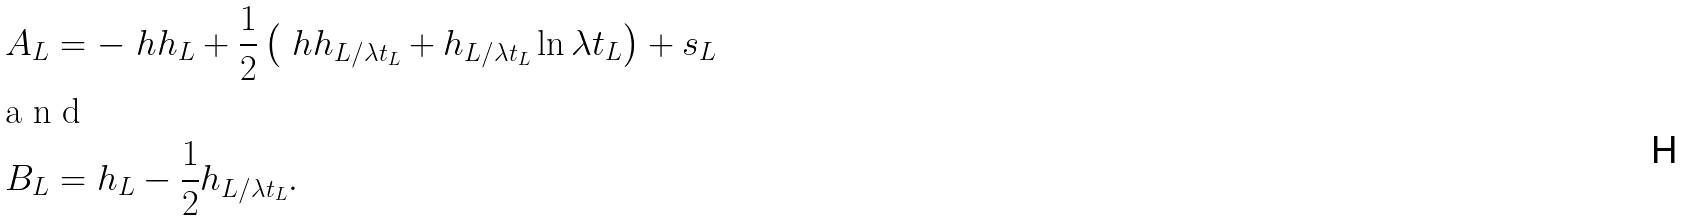<formula> <loc_0><loc_0><loc_500><loc_500>A _ { L } & = - \ h h _ { L } + \frac { 1 } { 2 } \left ( \ h h _ { L / \lambda t _ { L } } + h _ { L / \lambda t _ { L } } \ln \lambda t _ { L } \right ) + s _ { L } \intertext { a n d } B _ { L } & = h _ { L } - \frac { 1 } { 2 } h _ { L / \lambda t _ { L } } .</formula> 